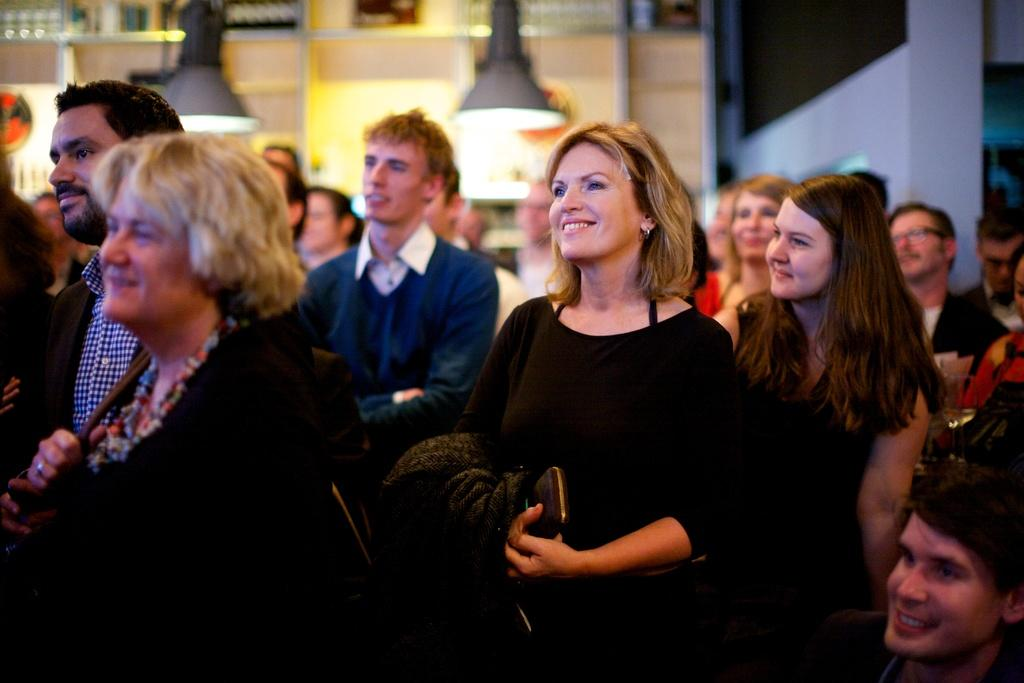How many people are in the image? There is a group of people in the image, but the exact number cannot be determined from the provided facts. What can be seen behind the people in the image? There are lights visible behind the people in the image. What is in the background of the image? There is a wall in the background of the image. How is the background of the image depicted? The background of the image is blurred. What type of toys are being traded among the people in the image? There is no mention of toys or trading in the image; it only shows a group of people with lights behind them and a blurred background. 